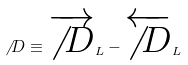Convert formula to latex. <formula><loc_0><loc_0><loc_500><loc_500>\not \, D \equiv \overrightarrow { \not \, D } _ { L } - \overleftarrow { \not \, D } _ { L }</formula> 